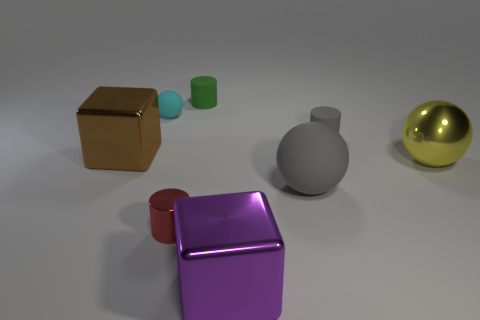Do the purple shiny thing and the green thing have the same shape?
Your answer should be very brief. No. How many other objects are the same size as the gray rubber ball?
Offer a very short reply. 3. How many things are objects that are on the left side of the big yellow metal object or small cylinders?
Give a very brief answer. 7. What is the color of the large rubber thing?
Make the answer very short. Gray. What is the material of the cube to the right of the red metal cylinder?
Ensure brevity in your answer.  Metal. There is a red thing; does it have the same shape as the gray matte thing that is on the left side of the gray matte cylinder?
Provide a short and direct response. No. Is the number of tiny red metallic objects greater than the number of small purple shiny cylinders?
Offer a terse response. Yes. Is there any other thing that has the same color as the metallic cylinder?
Your response must be concise. No. There is a large yellow object that is the same material as the purple thing; what shape is it?
Your response must be concise. Sphere. What is the material of the large sphere on the left side of the object right of the gray rubber cylinder?
Keep it short and to the point. Rubber. 